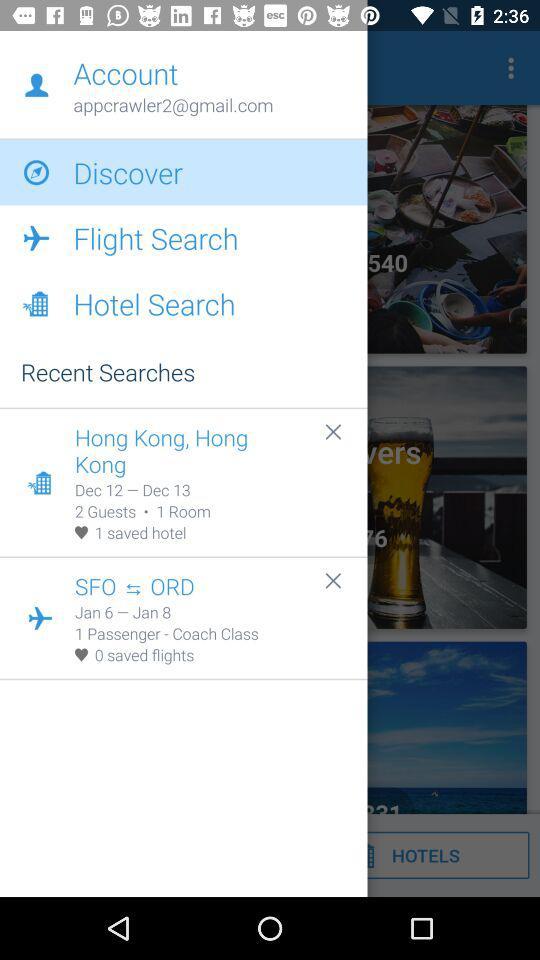Are there any saved flights? There are 0 saved flights. 